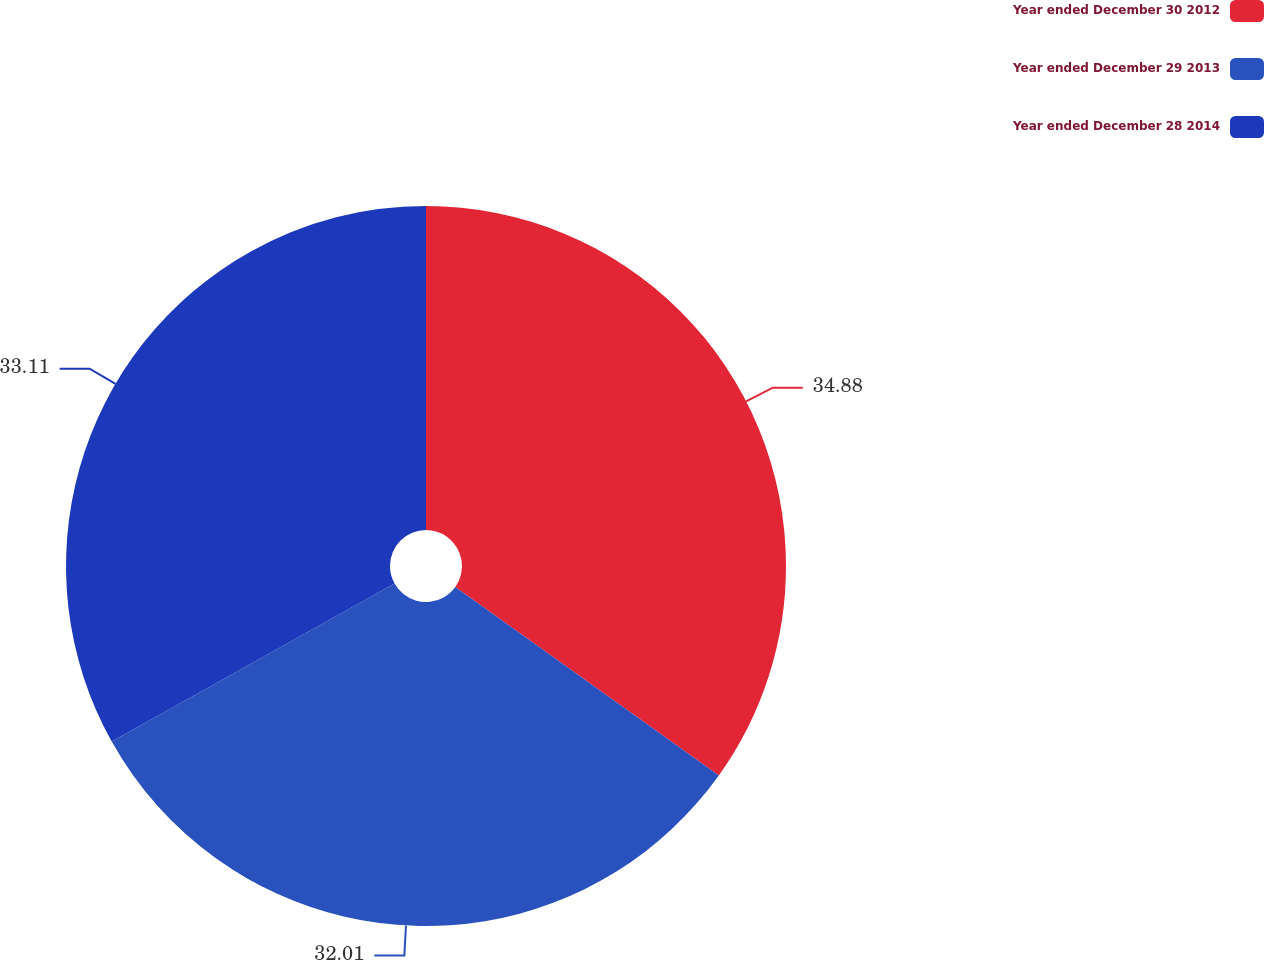<chart> <loc_0><loc_0><loc_500><loc_500><pie_chart><fcel>Year ended December 30 2012<fcel>Year ended December 29 2013<fcel>Year ended December 28 2014<nl><fcel>34.88%<fcel>32.01%<fcel>33.11%<nl></chart> 